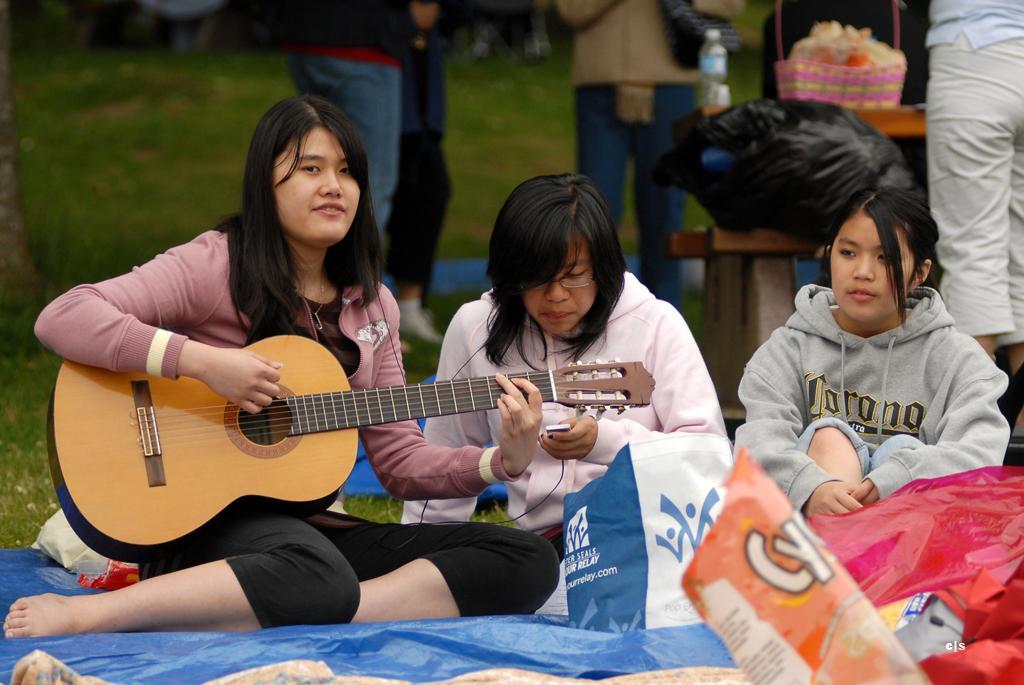Describe this image in one or two sentences. In Front portion of the picture we can see three women sitting. This woman is sitting and playing a guitar. On the background of the picture we can see few persons standing. This is a table and on the table we can see a black cover, a bottle and a basket. this is a green grass. This is a snacks packet. 